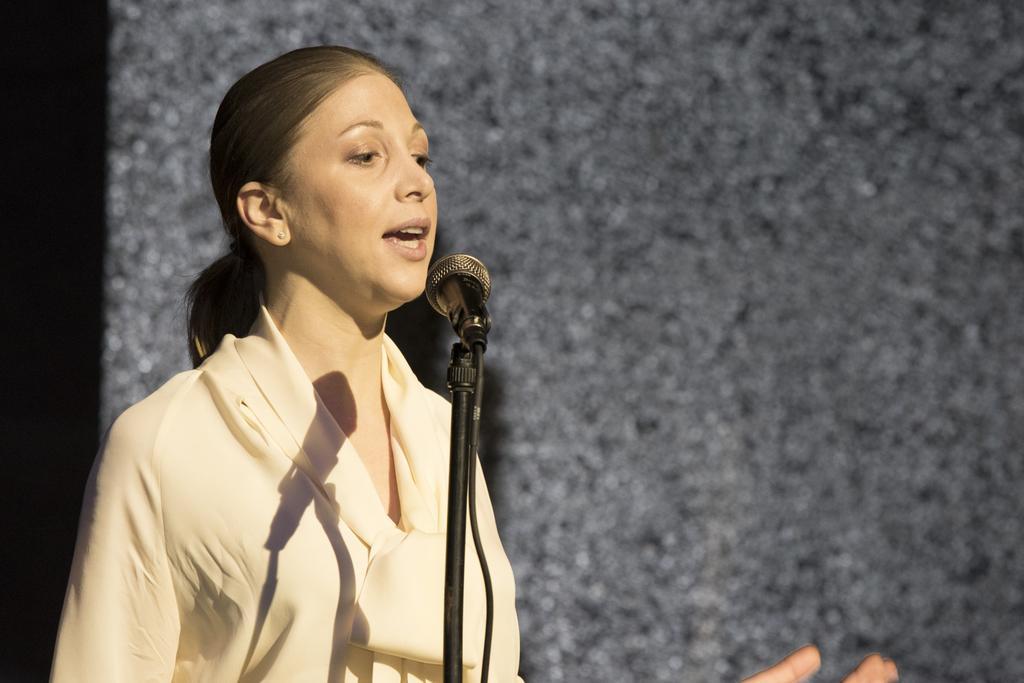Please provide a concise description of this image. In this image we can see a lady. In front of her there is a mic with mic stand. In the back there is a wall. 